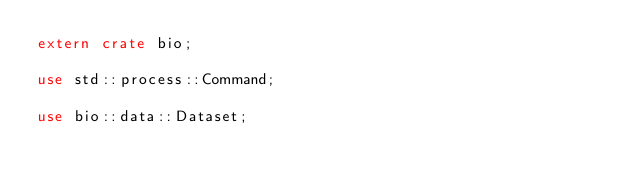<code> <loc_0><loc_0><loc_500><loc_500><_Rust_>extern crate bio;

use std::process::Command;

use bio::data::Dataset;
</code> 